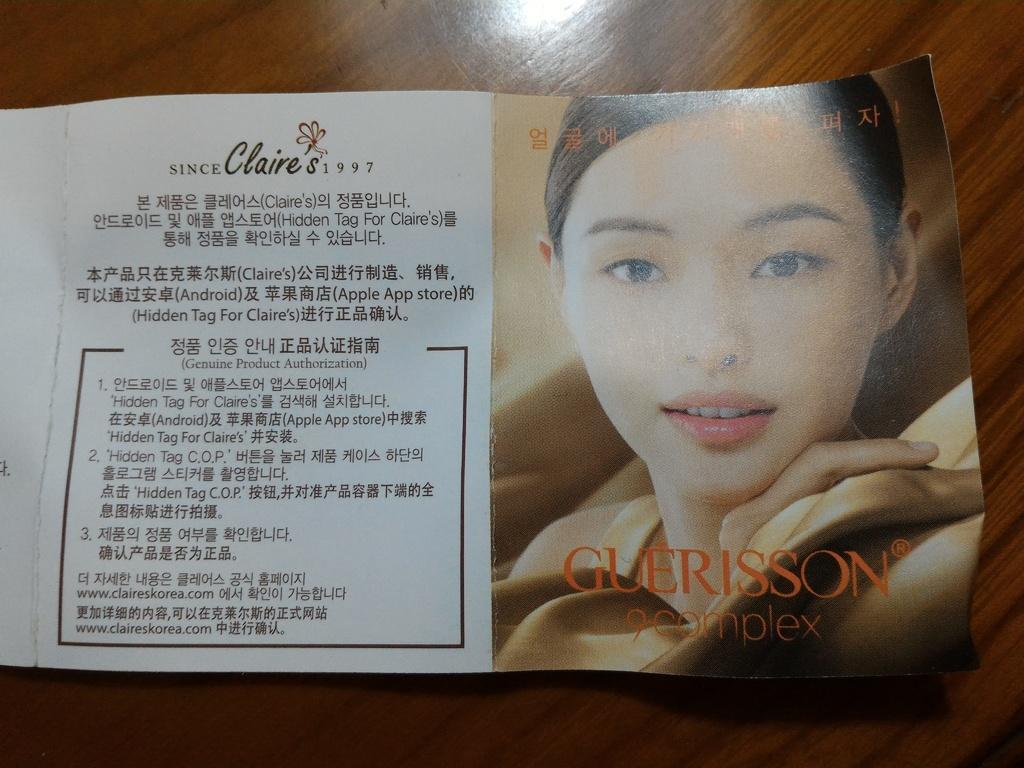Describe this image in one or two sentences. In this image there is a truncated Pamphlet on the surface, there is a person, text on the Pamphlet. 